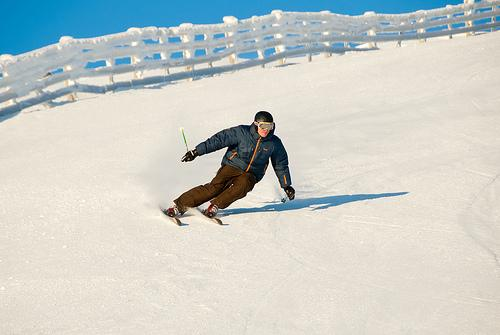Which task involves answering multiple-choice questions based on the visual information provided in the image? The multi-choice VQA task. Pick a task and briefly describe its goal in relation to the given image. The referential expression grounding task aims to correctly identify and localize specific objects and associated descriptors within the image. In a few words, explain what is happening in the scene of this image. A man is skiing down a snowy hill, with a snowy white fence in the background. Identify the color and type of the fence visible in the image. The fence is a long white fence, possibly made of wood. Describe the color and style of the man's ski equipment. The man is wearing brown skis, red boots, and is holding green ski poles. Describe the outfit the skier is wearing, including any accessories. The man is wearing a blue and orange coat, brown ski pants, black gloves, yellow goggles, and a black helmet. What is the weather like in the image and where is the man located? The weather appears to be cold and snowy, and the man is skiing on a hill with snow all around. Which task involves identifying a product in the image for advertising purposes? The product advertisement task. Is there any characteristic feature of the fence posts in the image? If so, what is it? The fence posts are covered in snow, giving them a snow-white appearance. 